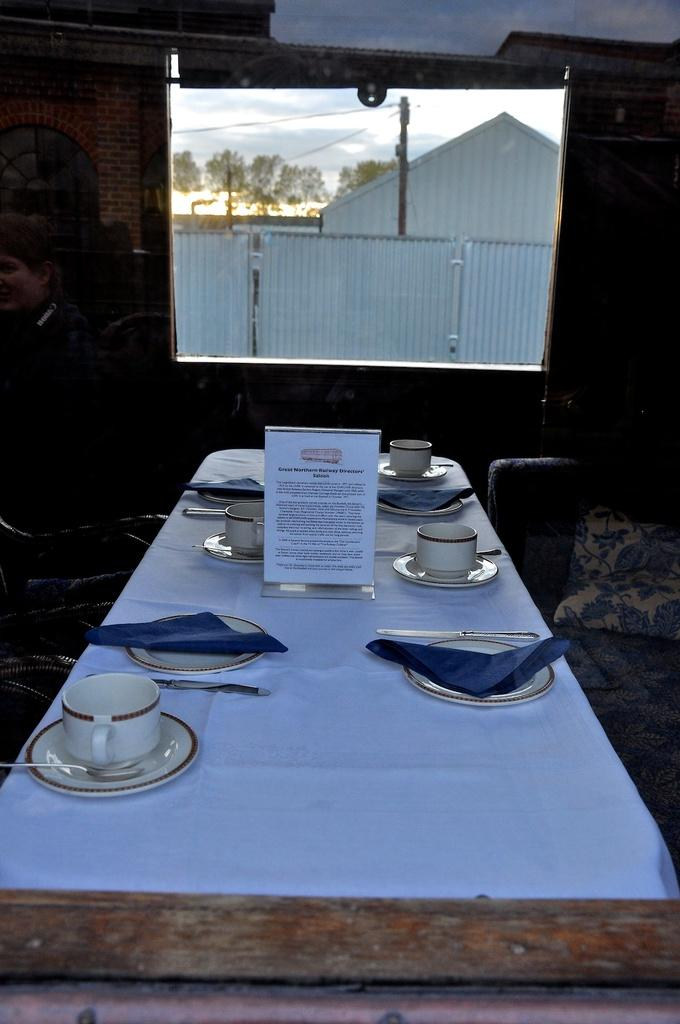What is the main piece of furniture in the image? There is a table in the image. What is covering the table? There is a tablecloth on the table. What items can be seen on the table? There are cup and saucers, as well as tissues, on the table. What can be seen through the window in the image? Houses, trees, the sky, and a pole are visible through the window. How deep is the quicksand in the image? There is no quicksand present in the image. What advice would the mother in the image give to her child? There is no mother or child present in the image, so it is not possible to answer this question. 